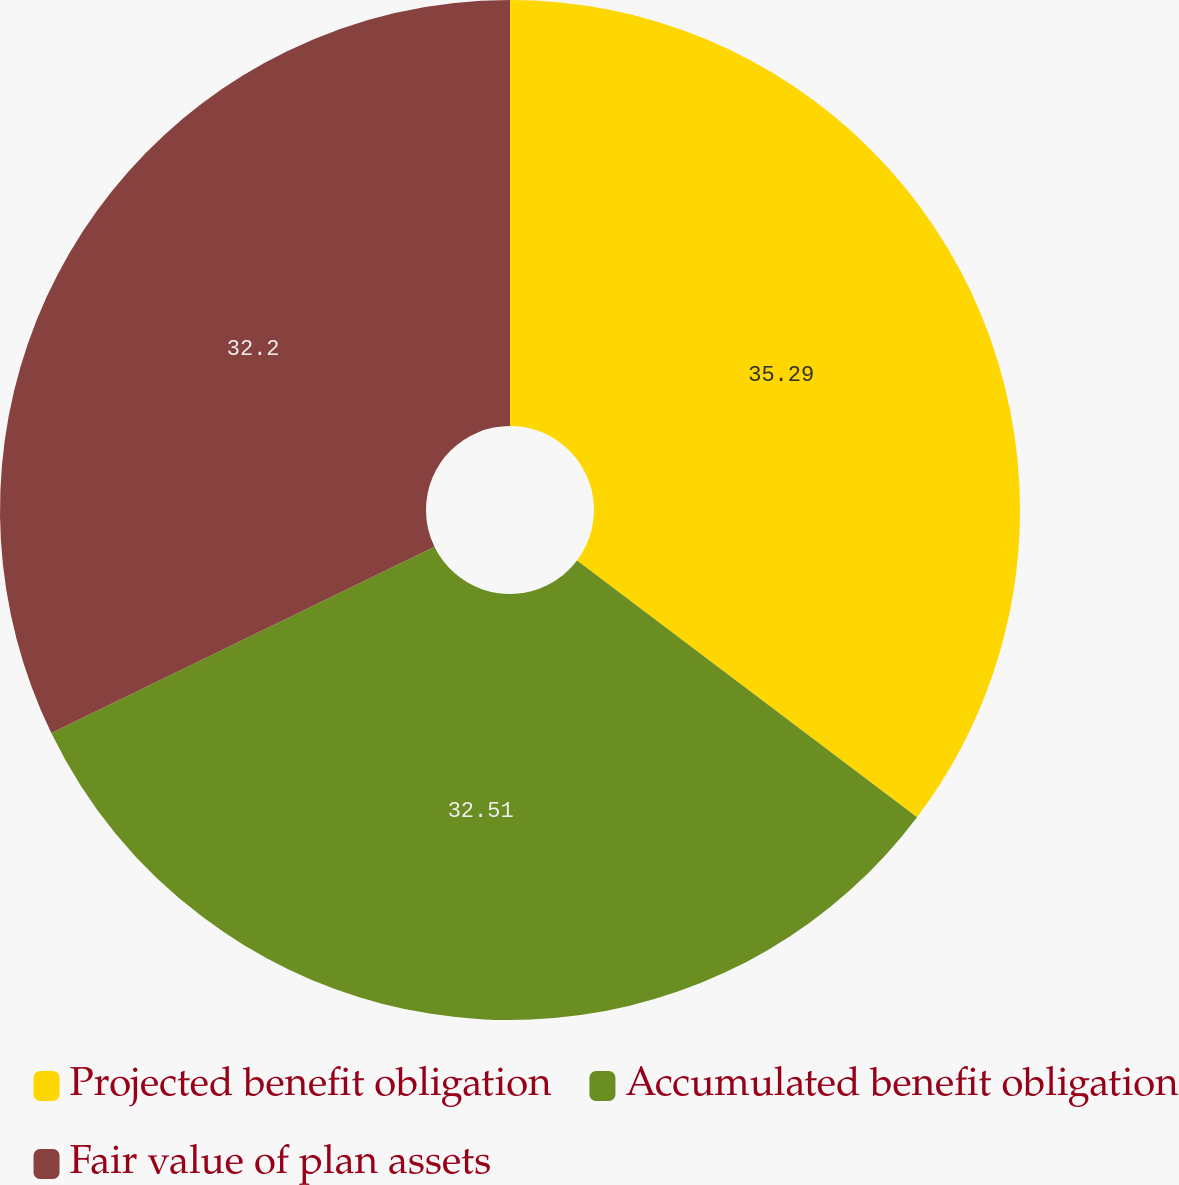Convert chart. <chart><loc_0><loc_0><loc_500><loc_500><pie_chart><fcel>Projected benefit obligation<fcel>Accumulated benefit obligation<fcel>Fair value of plan assets<nl><fcel>35.29%<fcel>32.51%<fcel>32.2%<nl></chart> 